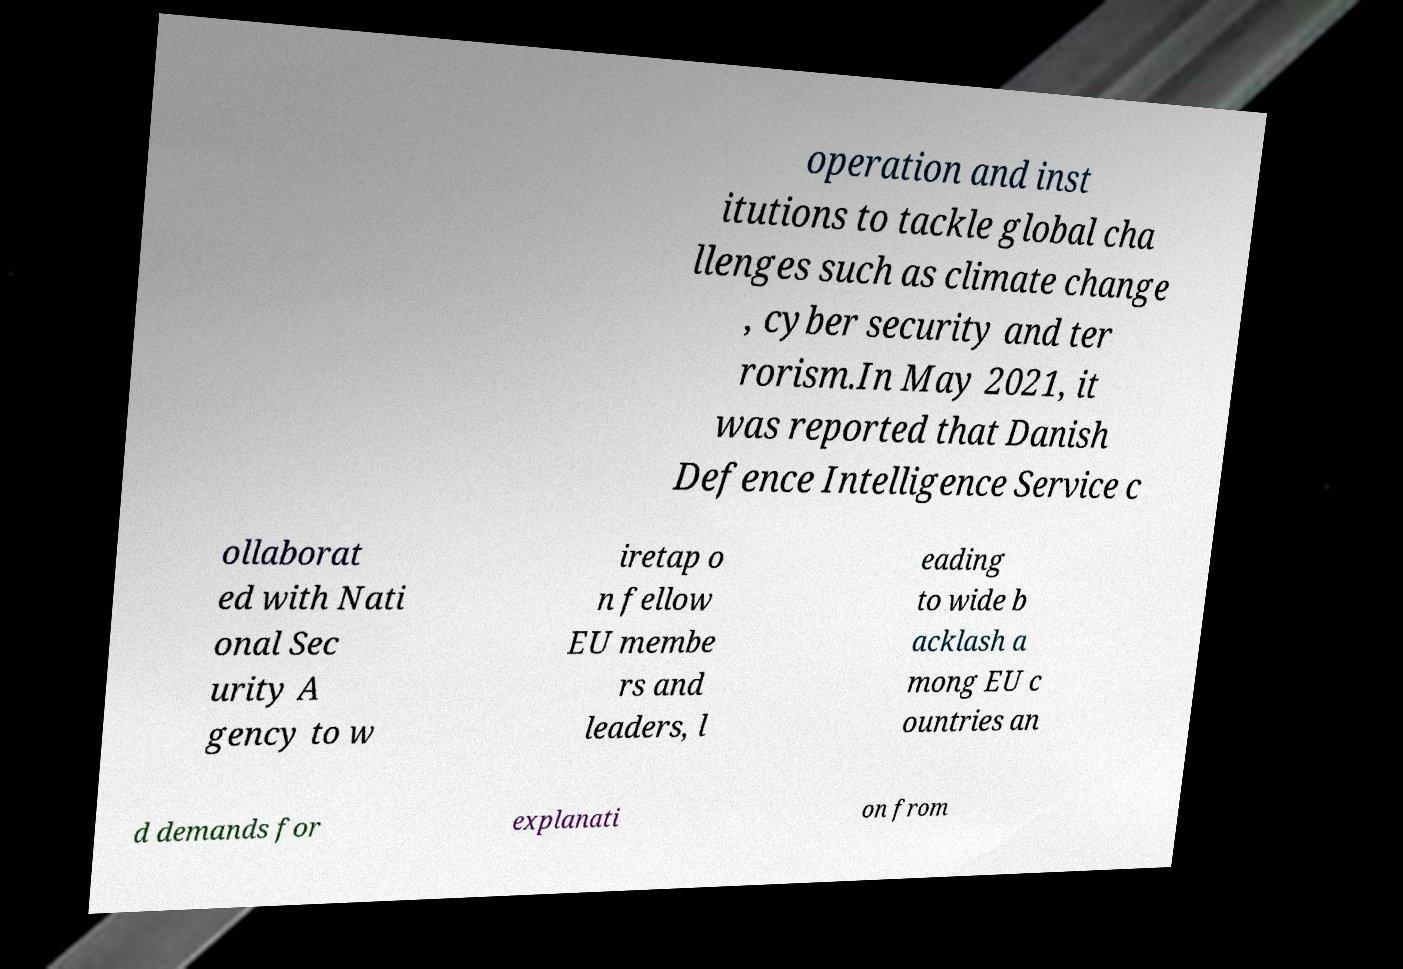Please identify and transcribe the text found in this image. operation and inst itutions to tackle global cha llenges such as climate change , cyber security and ter rorism.In May 2021, it was reported that Danish Defence Intelligence Service c ollaborat ed with Nati onal Sec urity A gency to w iretap o n fellow EU membe rs and leaders, l eading to wide b acklash a mong EU c ountries an d demands for explanati on from 